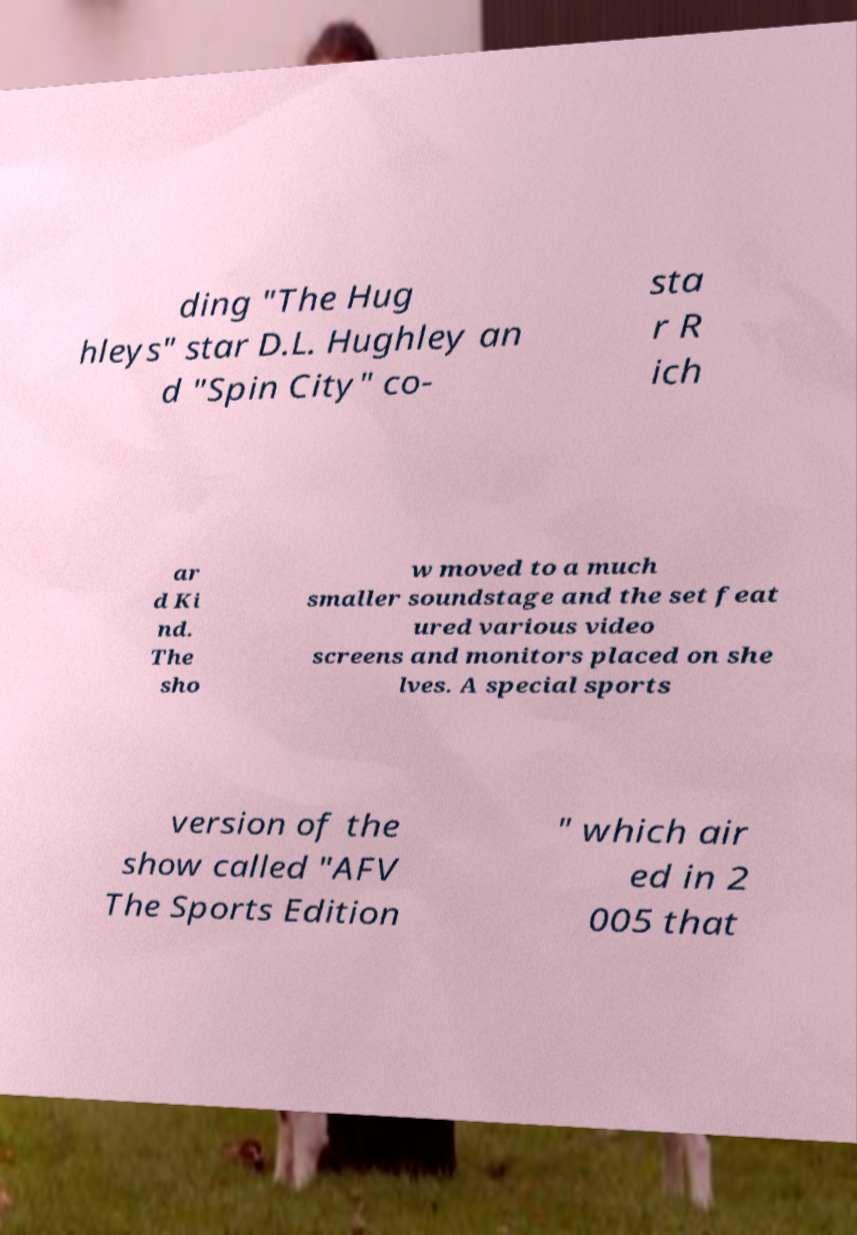Can you accurately transcribe the text from the provided image for me? ding "The Hug hleys" star D.L. Hughley an d "Spin City" co- sta r R ich ar d Ki nd. The sho w moved to a much smaller soundstage and the set feat ured various video screens and monitors placed on she lves. A special sports version of the show called "AFV The Sports Edition " which air ed in 2 005 that 